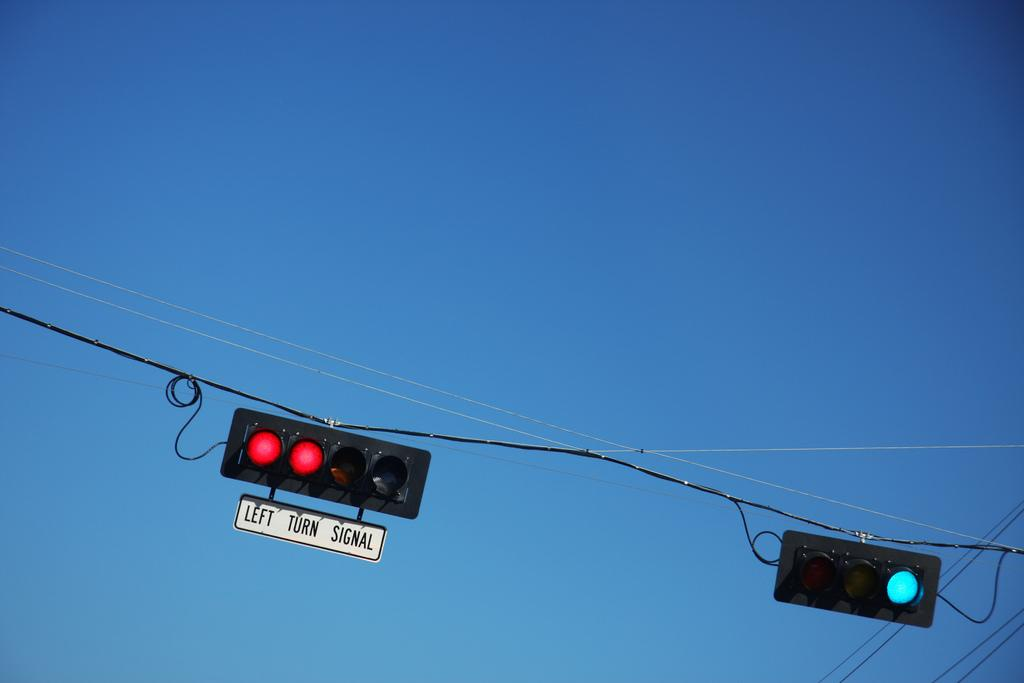<image>
Relay a brief, clear account of the picture shown. a red light that has left turn signal written on it 